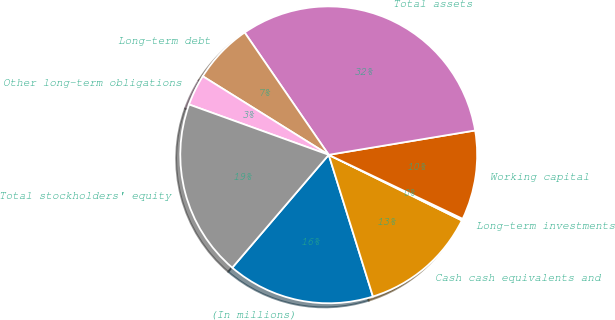Convert chart to OTSL. <chart><loc_0><loc_0><loc_500><loc_500><pie_chart><fcel>(In millions)<fcel>Cash cash equivalents and<fcel>Long-term investments<fcel>Working capital<fcel>Total assets<fcel>Long-term debt<fcel>Other long-term obligations<fcel>Total stockholders' equity<nl><fcel>16.07%<fcel>12.9%<fcel>0.19%<fcel>9.72%<fcel>31.96%<fcel>6.54%<fcel>3.37%<fcel>19.25%<nl></chart> 